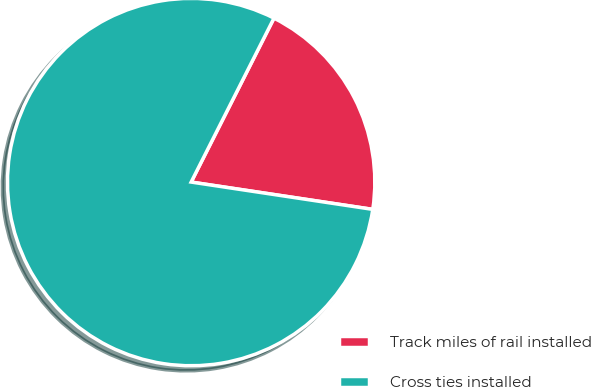Convert chart. <chart><loc_0><loc_0><loc_500><loc_500><pie_chart><fcel>Track miles of rail installed<fcel>Cross ties installed<nl><fcel>19.93%<fcel>80.07%<nl></chart> 